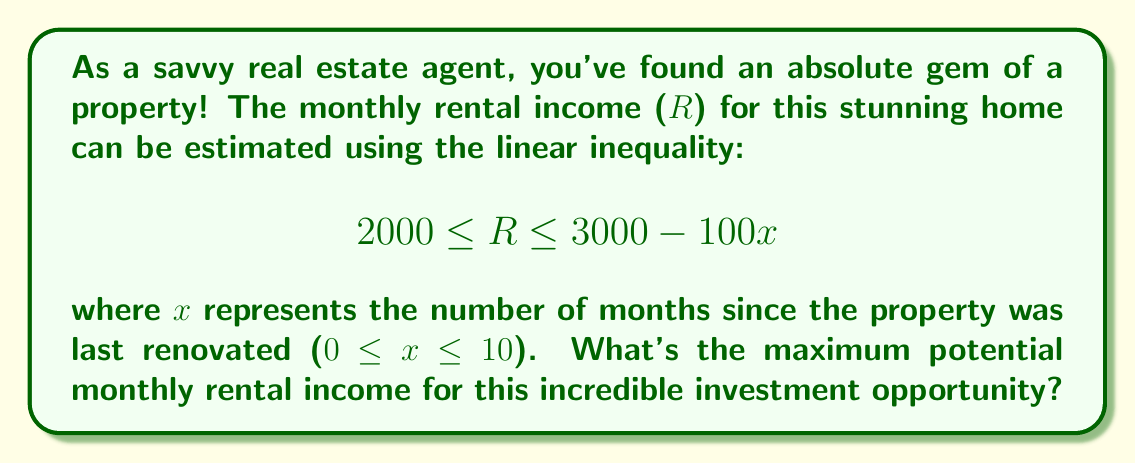Can you solve this math problem? To find the maximum potential monthly rental income, we need to follow these steps:

1) The inequality given is:
   $$2000 \leq R \leq 3000 - 100x$$

2) The maximum value of $R$ will occur when the right-hand side of the inequality is at its maximum.

3) The right-hand side (3000 - 100x) will be at its maximum when x is at its minimum value.

4) We're told that 0 ≤ x ≤ 10, so the minimum value of x is 0.

5) When x = 0, the right-hand side becomes:
   $$3000 - 100(0) = 3000$$

6) Therefore, the maximum value of $R$ is $3000.

This means that the maximum potential monthly rental income for this fantastic property is $3000, which is an absolutely phenomenal opportunity for any investor!
Answer: $3000 